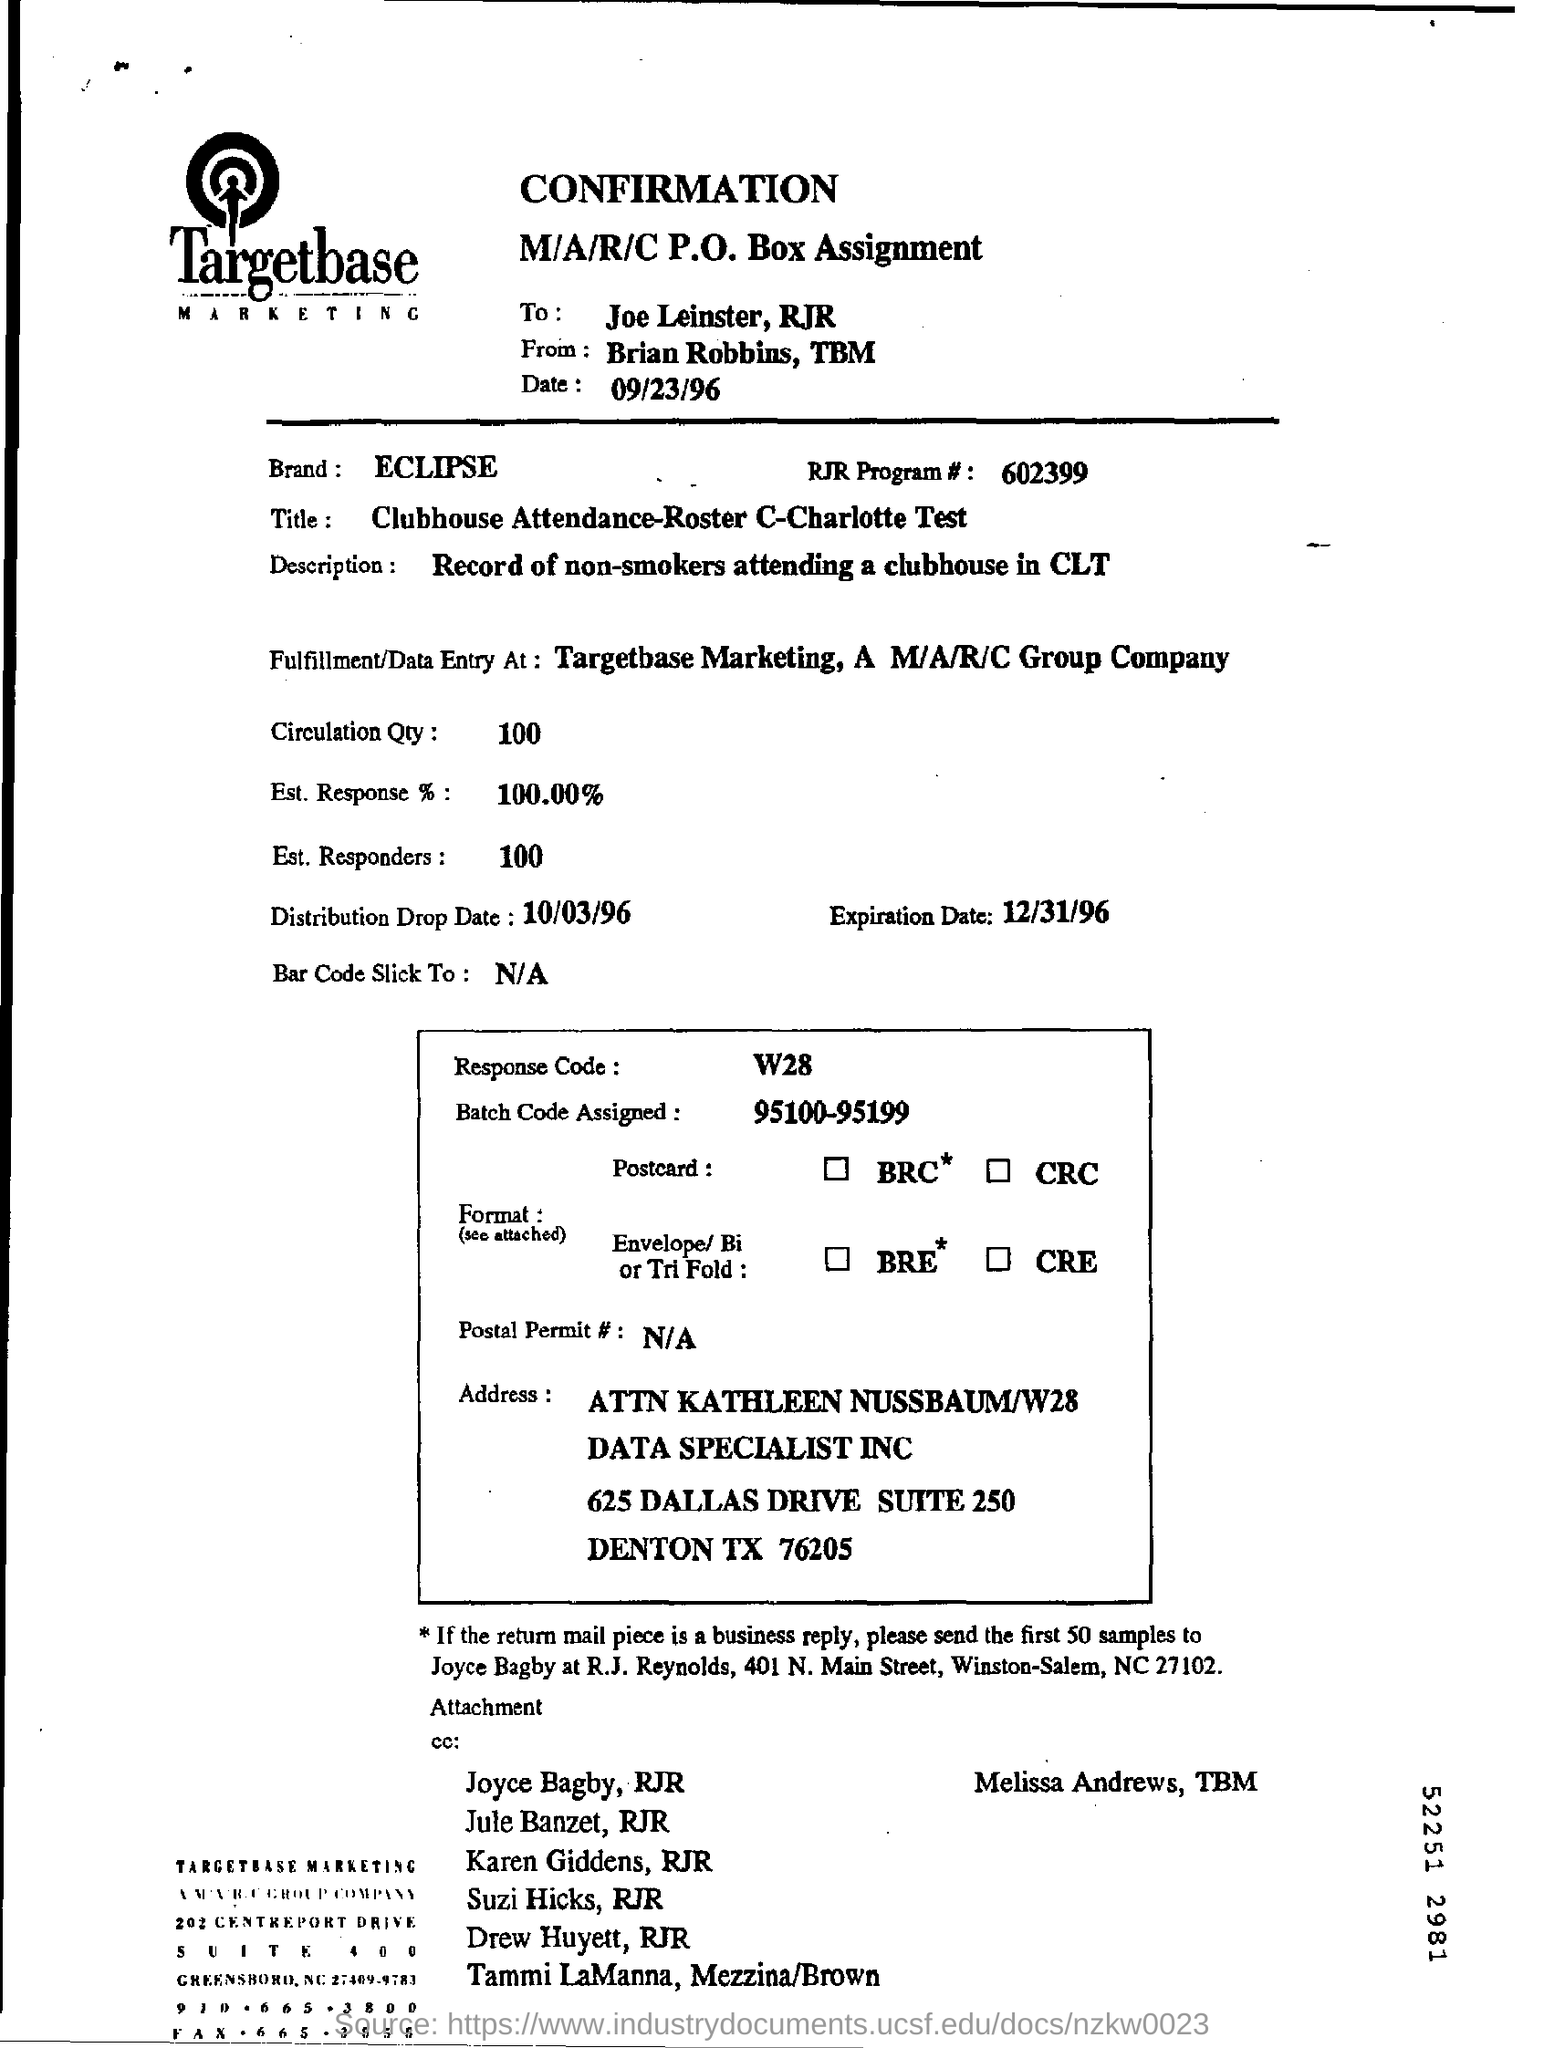What is the heading of the document?
Provide a succinct answer. CONFIRMATION. What is the name of the marketing company?
Give a very brief answer. Targetbase. What is the name of the Brand?
Offer a very short reply. ECLIPSE. What is the Expiration Date mentioned?
Provide a short and direct response. 12/31/96. 